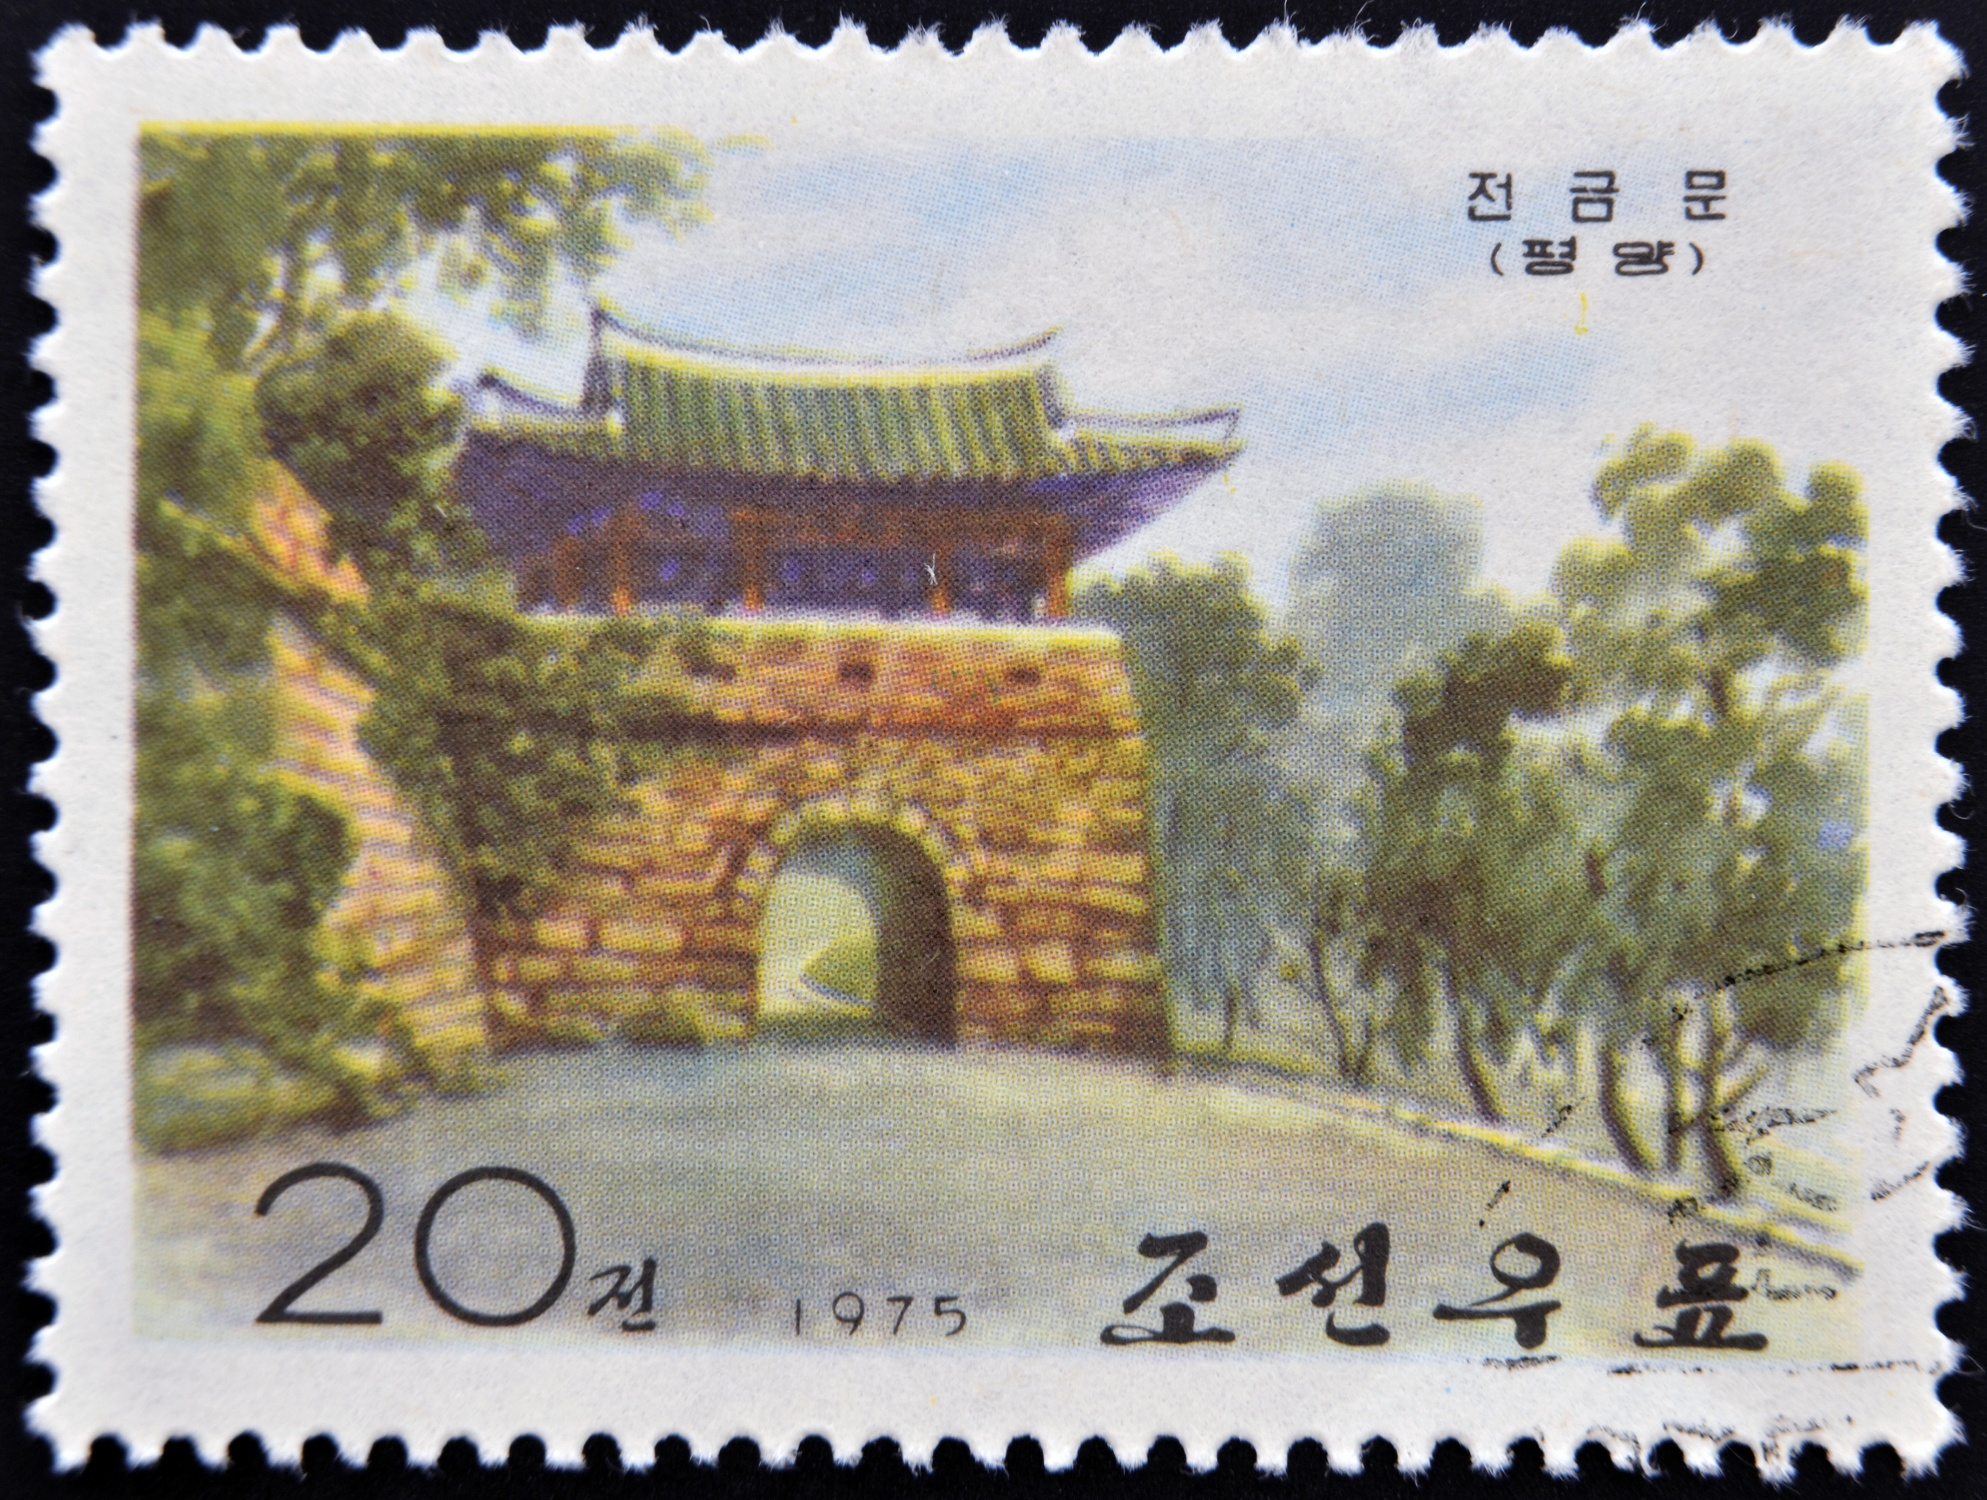What can you infer about the cultural significance of the gate in the image? The gate in the image likely holds significant cultural importance, reflecting traditional Korean architecture and heritage. Gates such as this one often serve as historical and cultural landmarks, encapsulating the craftsmanship, aesthetic principles, and cultural values of the period they were constructed in. The upturned eaves and the green roof are typical of Korean design that emphasizes harmony with nature, a fundamental aspect of Korean culture. Additionally, the lush garden signifies the importance of nature and tranquility in Korean tradition. Stamps like this serve to commemorate and preserve historical structures, educating the public about the nation's cultural and architectural heritage. 